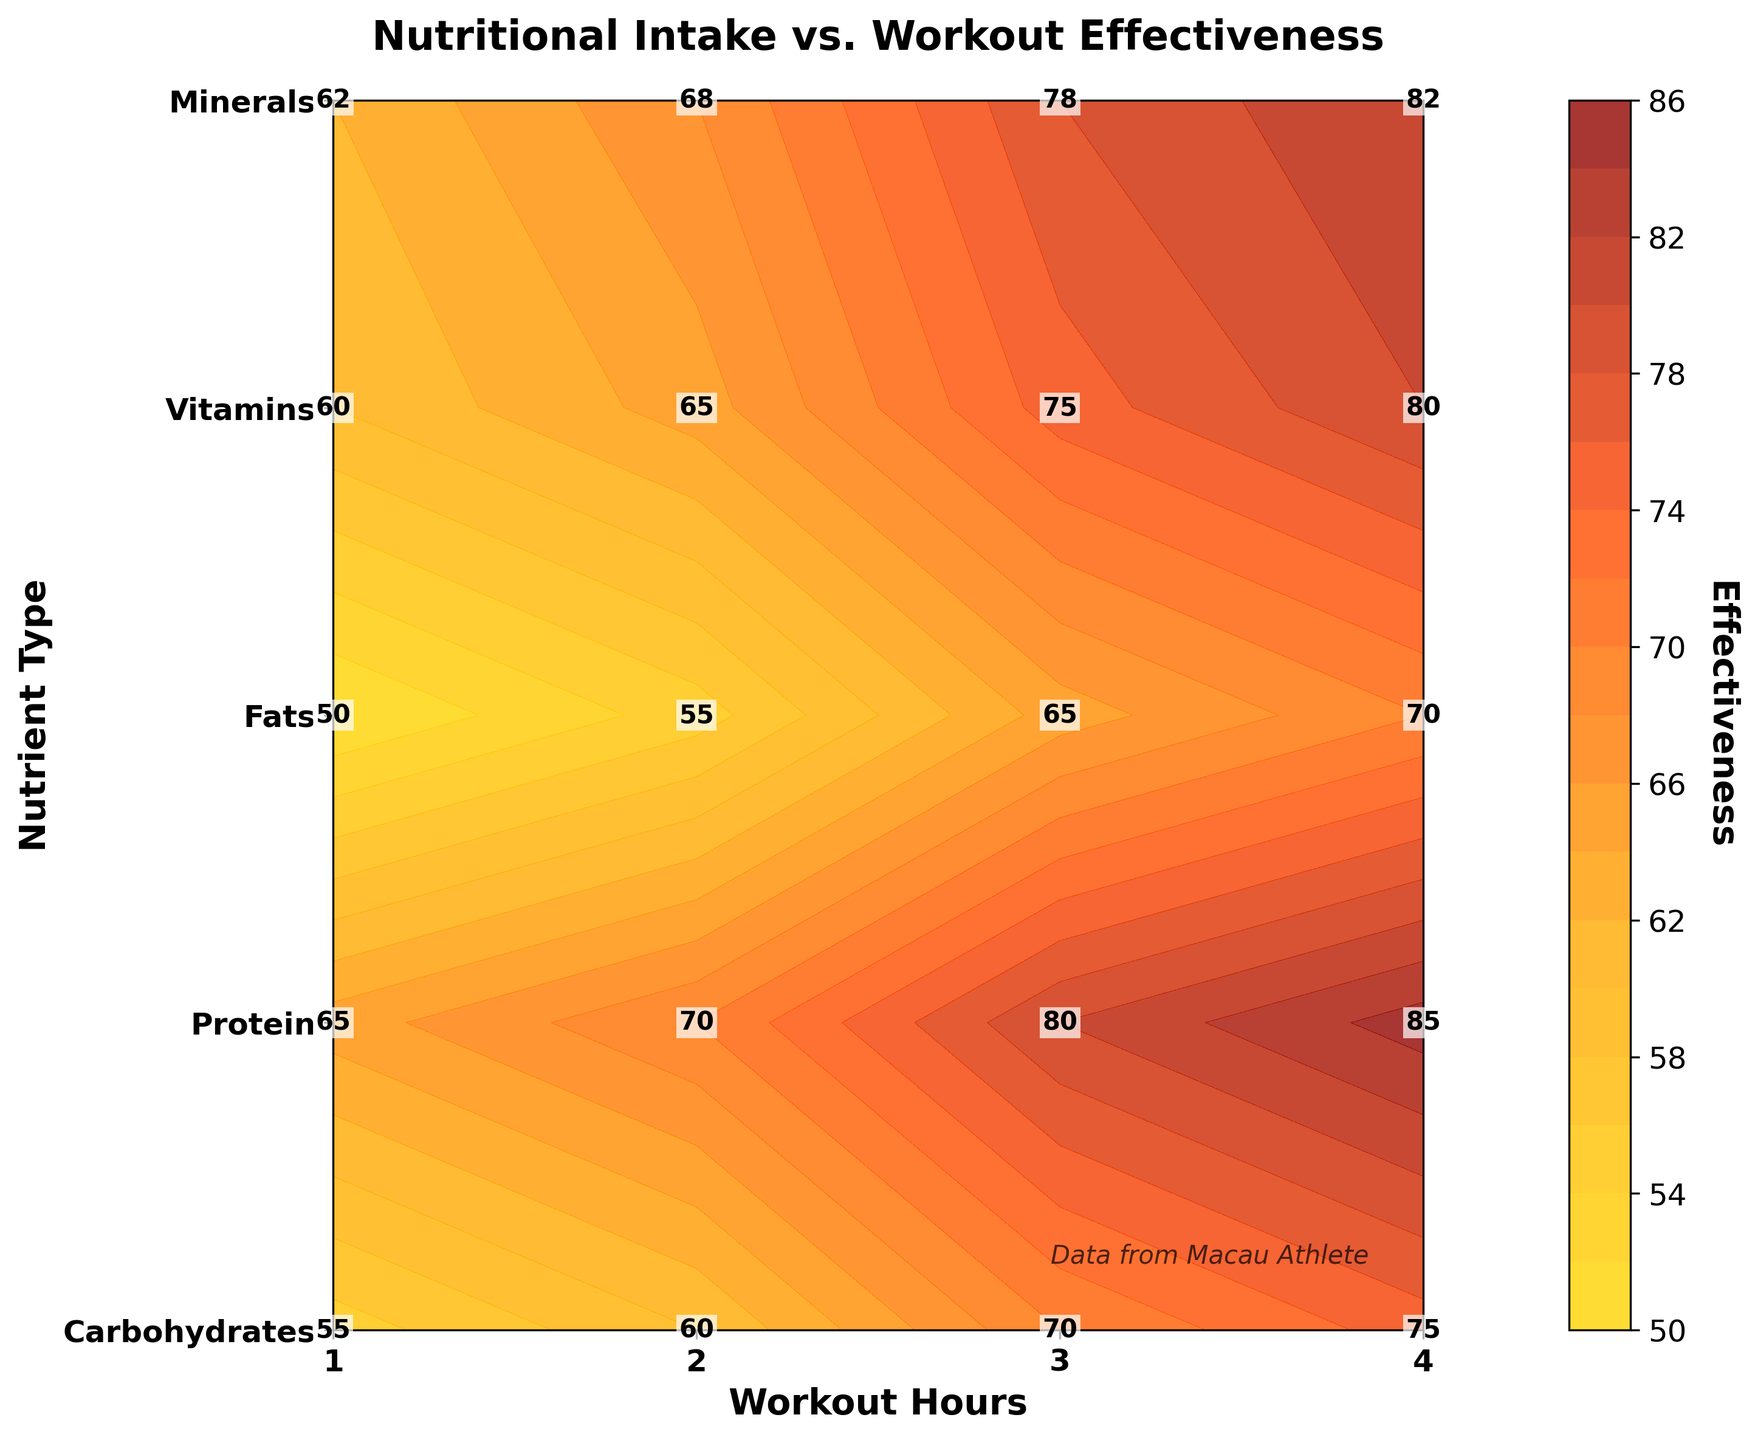What is the title of the plot? The title is typically located at the top of the plot. In this case, it states the main topic of the figure.
Answer: Nutritional Intake vs. Workout Effectiveness What are the labels on the x-axis and y-axis? The x-axis label indicates what the x-values represent, and the y-axis label does the same for y-values. These labels are located along their respective axes in the plot.
Answer: x-axis: Workout Hours, y-axis: Nutrient Type Which nutrient has the highest effectiveness with 4 workout hours? Locate the 4-hour workout column and find the highest number among the different nutrients listed along the y-axis.
Answer: Protein What is the effectiveness of Carbohydrates with 2 hours of workout? Find the intersection of the Carbohydrates row and the 2-hour workout column and read the effectiveness value.
Answer: 60 Between Protein and Vitamins, which nutrient type shows higher effectiveness with 3 hours of workout? Find the effectiveness of Protein and Vitamins at the 3-hour workout column and compare them.
Answer: Protein What is the average effectiveness of Minerals across all workout hours? Sum the effectiveness values for Minerals at 1, 2, 3, and 4 hours, and divide by the number of data points (4). (62 + 68 + 78 + 82) / 4 = 72.5
Answer: 72.5 Which nutrient shows an increasing trend in effectiveness as the workout hours increase? Observe the trend in numbers across workout hours for each nutrient and note any increases from 1 to 4 hours. All nutrients show an increasing trend.
Answer: All nutrients What is the difference in effectiveness between Carbohydrates and Fats for 1 hour of workout? Subtract the effectiveness value of Fats from that of Carbohydrates when the workout hour is 1. 55 - 50 = 5
Answer: 5 How does the color of the contour plot change as effectiveness increases? Color changes can be interpreted by observing the color gradient from low to high effectiveness values in the plot.
Answer: It changes from gold to dark red What is the overall trend in effectiveness for longer workout hours across all nutrients? Scan across all nutrient rows at increasing workout hours and observe whether effectiveness generally increases or decreases.
Answer: Increasing 